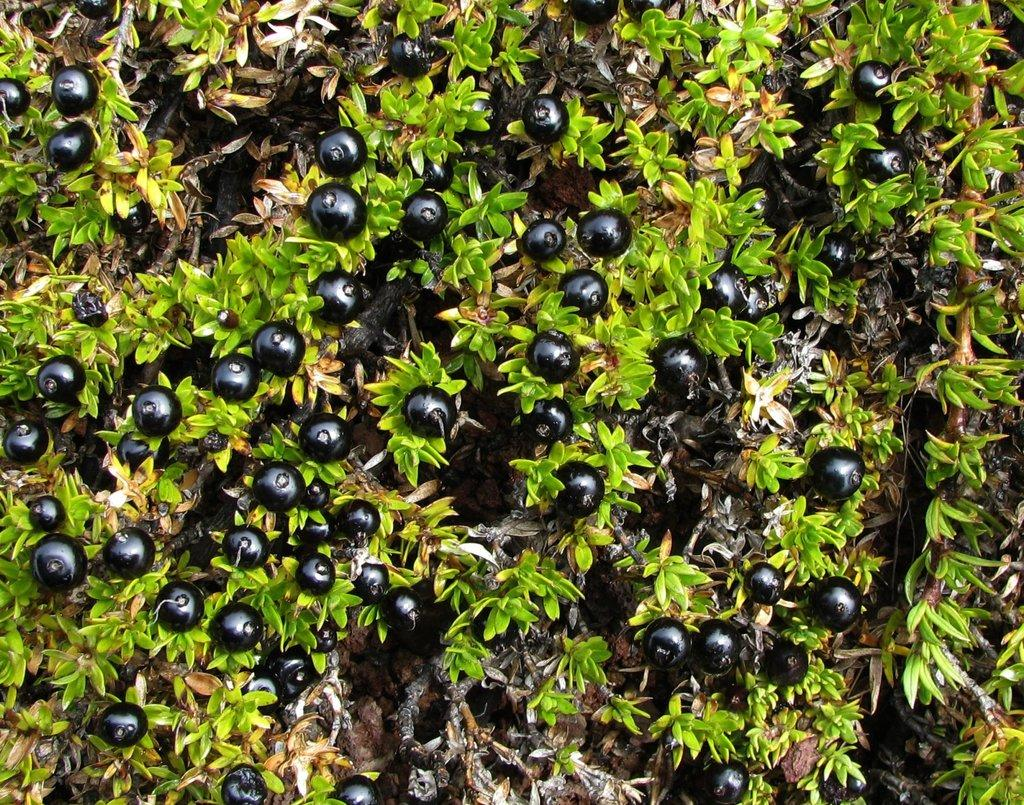What type of fruit can be seen on the plant in the image? There are berries on a plant in the image. Can you describe the plant that the berries are growing on? Unfortunately, the image only shows the berries and not the plant itself. What might someone do with the berries in the image? Someone might pick the berries to eat or use them in a recipe. What type of mask is being worn by the berries in the image? There are no masks present in the image, as it features berries on a plant. 